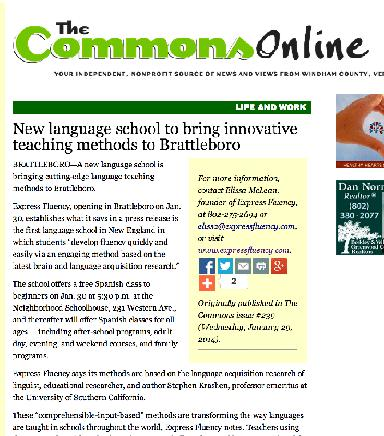What type of school is mentioned in the image? The image showcases a promotional feature on a new language school located in Brattleboro, which is dedicated to implementing innovative instructional methodologies designed to revolutionize language learning experiences. 